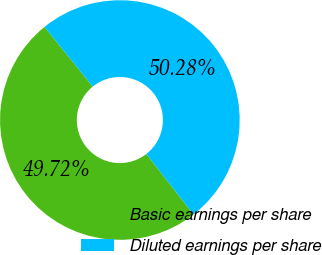<chart> <loc_0><loc_0><loc_500><loc_500><pie_chart><fcel>Basic earnings per share<fcel>Diluted earnings per share<nl><fcel>49.72%<fcel>50.28%<nl></chart> 